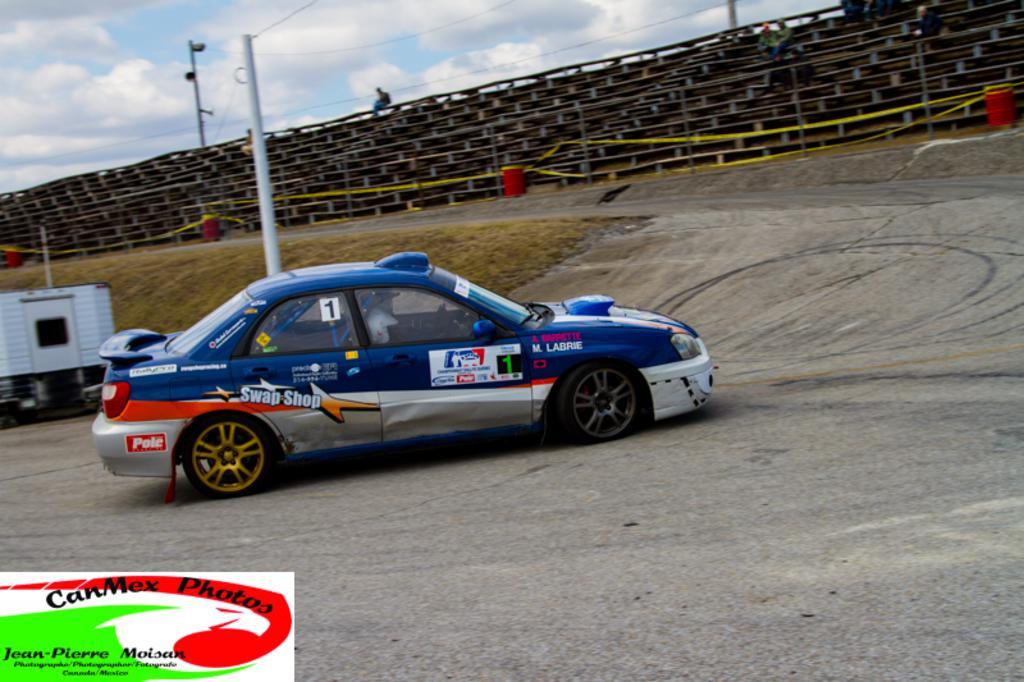Could you give a brief overview of what you see in this image? In this picture, there is a car moving towards the right. It is in blue in color. At the bottom, there is a road. On the top, there are stairs with poles. In the background, there is a sky with clouds. 